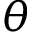<formula> <loc_0><loc_0><loc_500><loc_500>\theta</formula> 